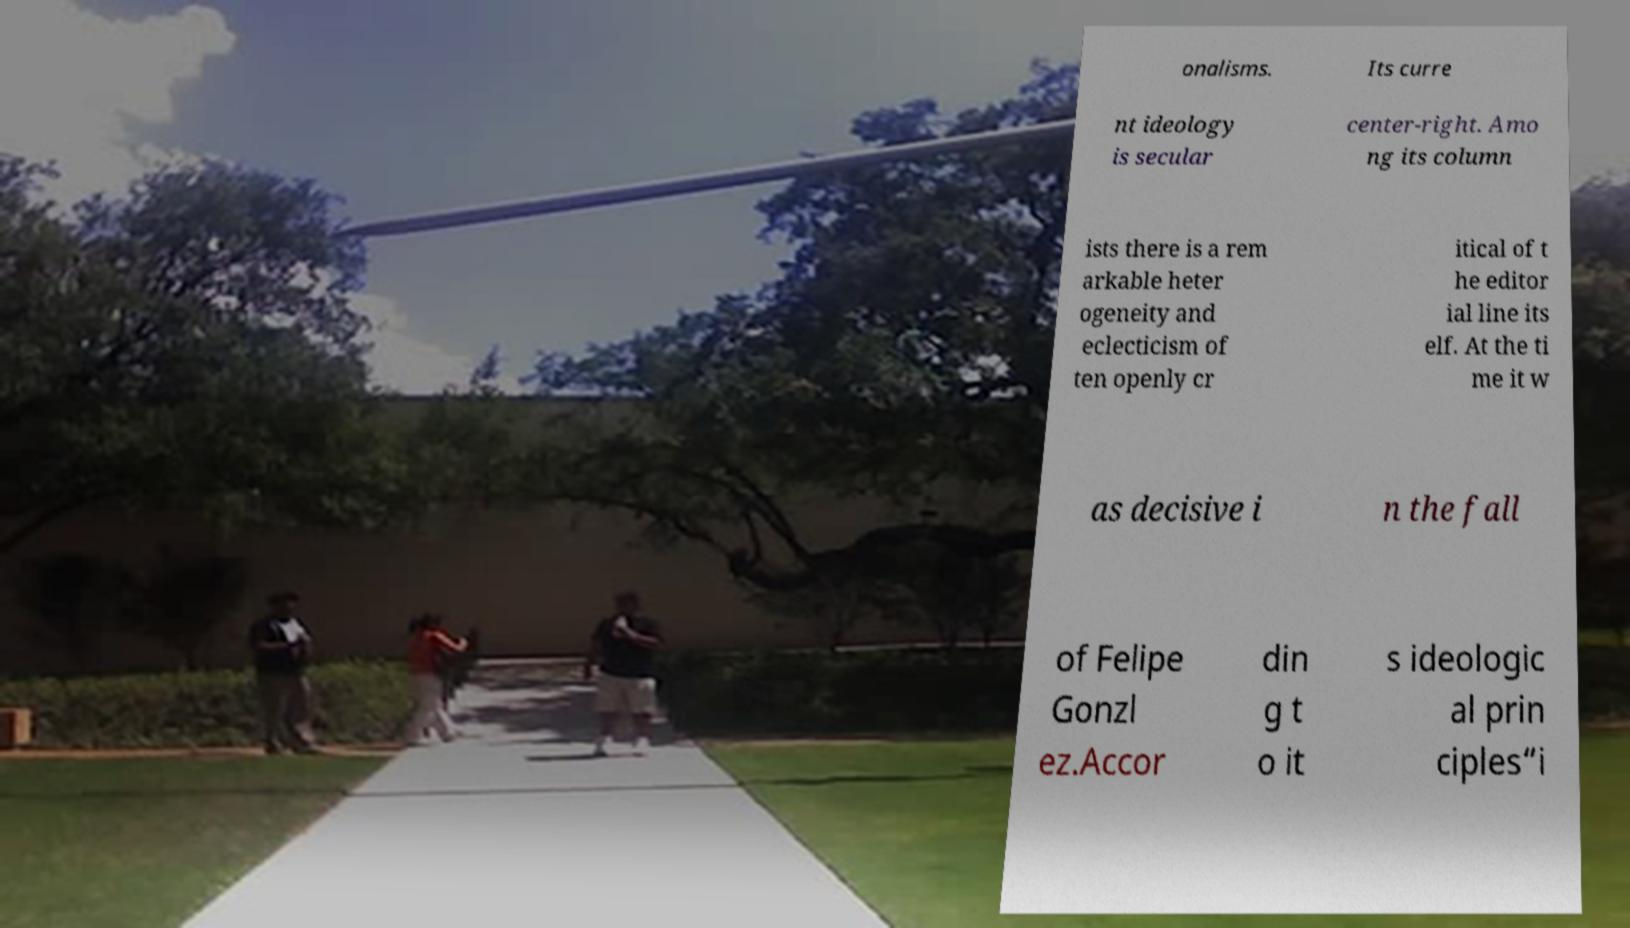What messages or text are displayed in this image? I need them in a readable, typed format. onalisms. Its curre nt ideology is secular center-right. Amo ng its column ists there is a rem arkable heter ogeneity and eclecticism of ten openly cr itical of t he editor ial line its elf. At the ti me it w as decisive i n the fall of Felipe Gonzl ez.Accor din g t o it s ideologic al prin ciples“i 